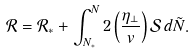<formula> <loc_0><loc_0><loc_500><loc_500>\mathcal { R } = \mathcal { R } _ { * } + \int _ { N _ { * } } ^ { N } 2 \left ( \frac { \eta _ { \perp } } { v } \right ) \mathcal { S } \, d \tilde { N } .</formula> 